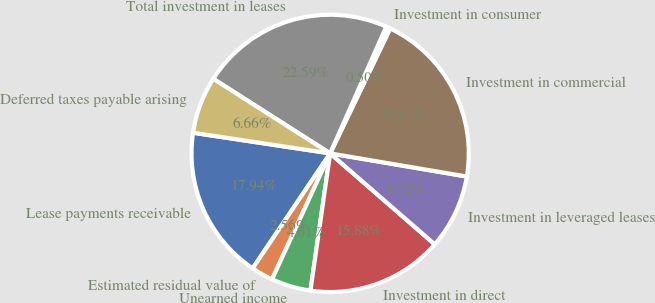Convert chart to OTSL. <chart><loc_0><loc_0><loc_500><loc_500><pie_chart><fcel>Lease payments receivable<fcel>Estimated residual value of<fcel>Unearned income<fcel>Investment in direct<fcel>Investment in leveraged leases<fcel>Investment in commercial<fcel>Investment in consumer<fcel>Total investment in leases<fcel>Deferred taxes payable arising<nl><fcel>17.94%<fcel>2.56%<fcel>4.61%<fcel>15.88%<fcel>8.72%<fcel>20.54%<fcel>0.5%<fcel>22.59%<fcel>6.66%<nl></chart> 